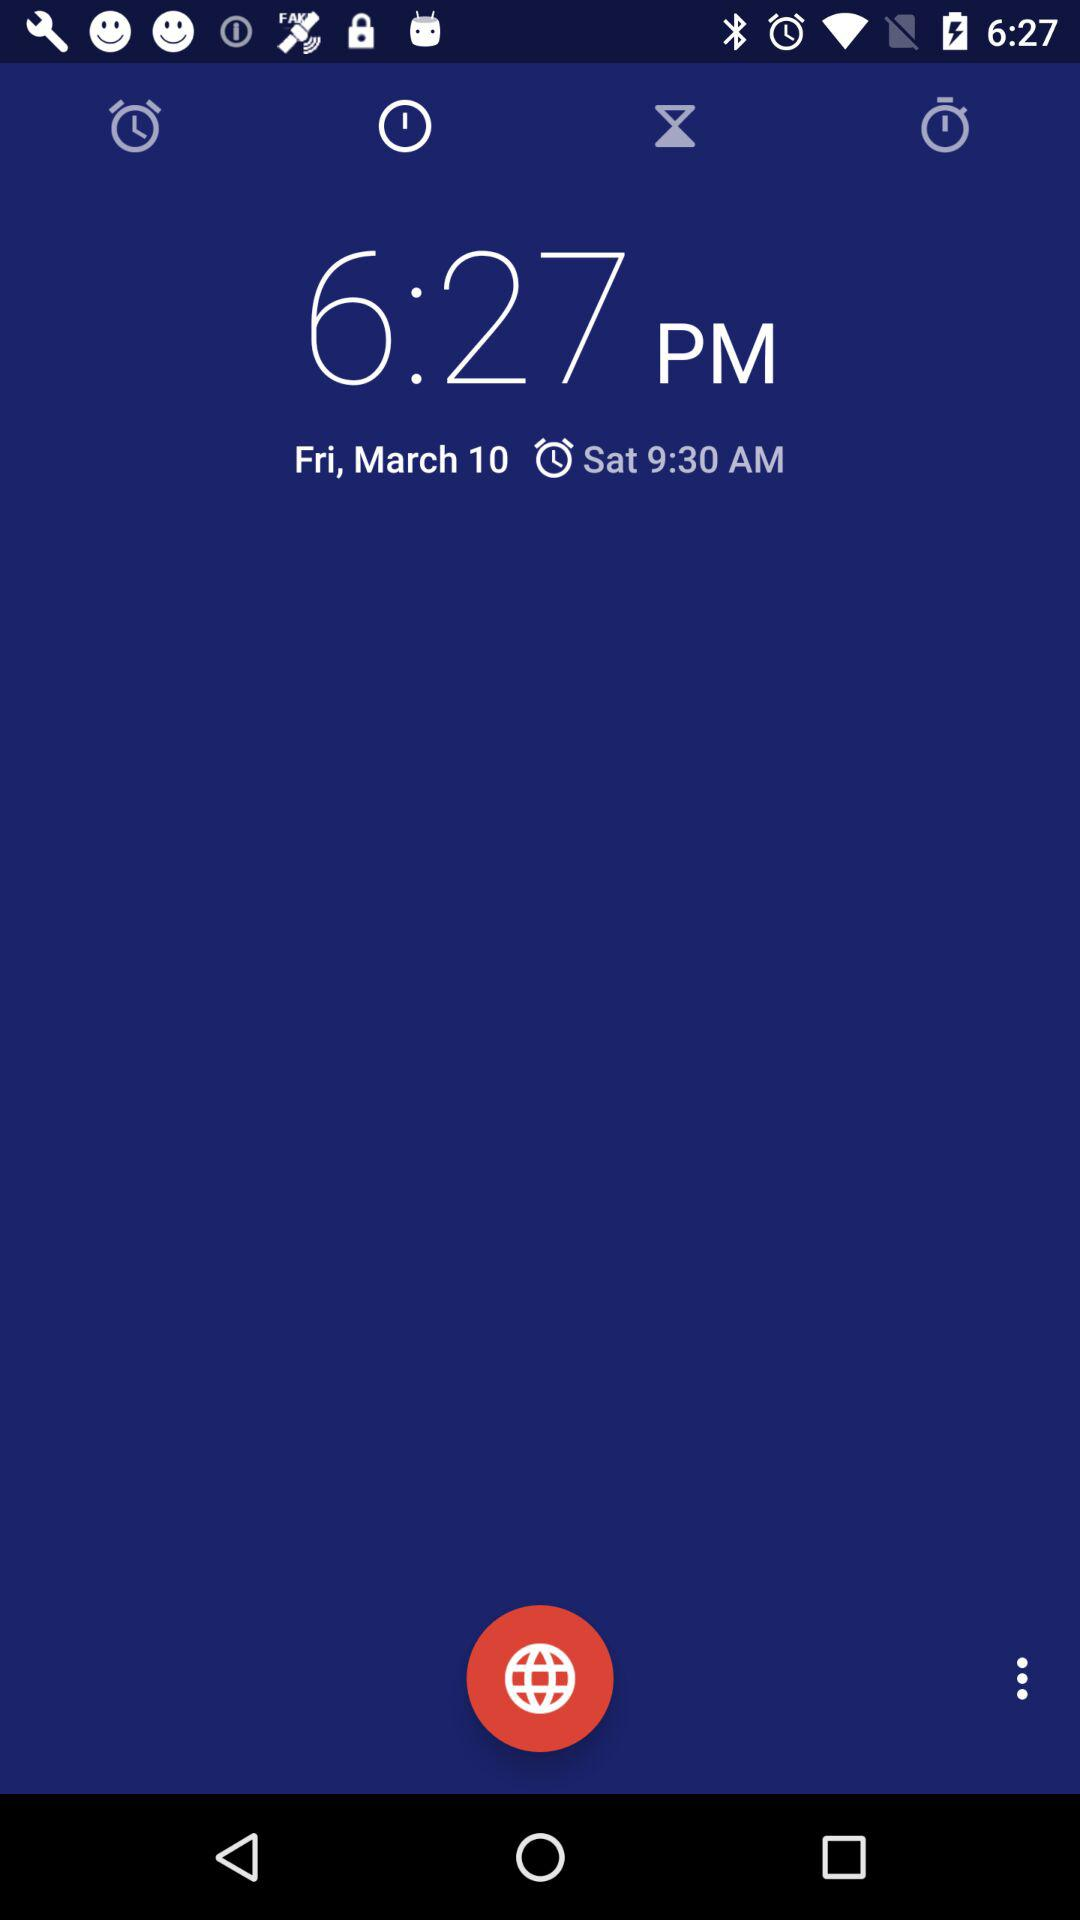What is the current time? The current time is 6:27 PM. 